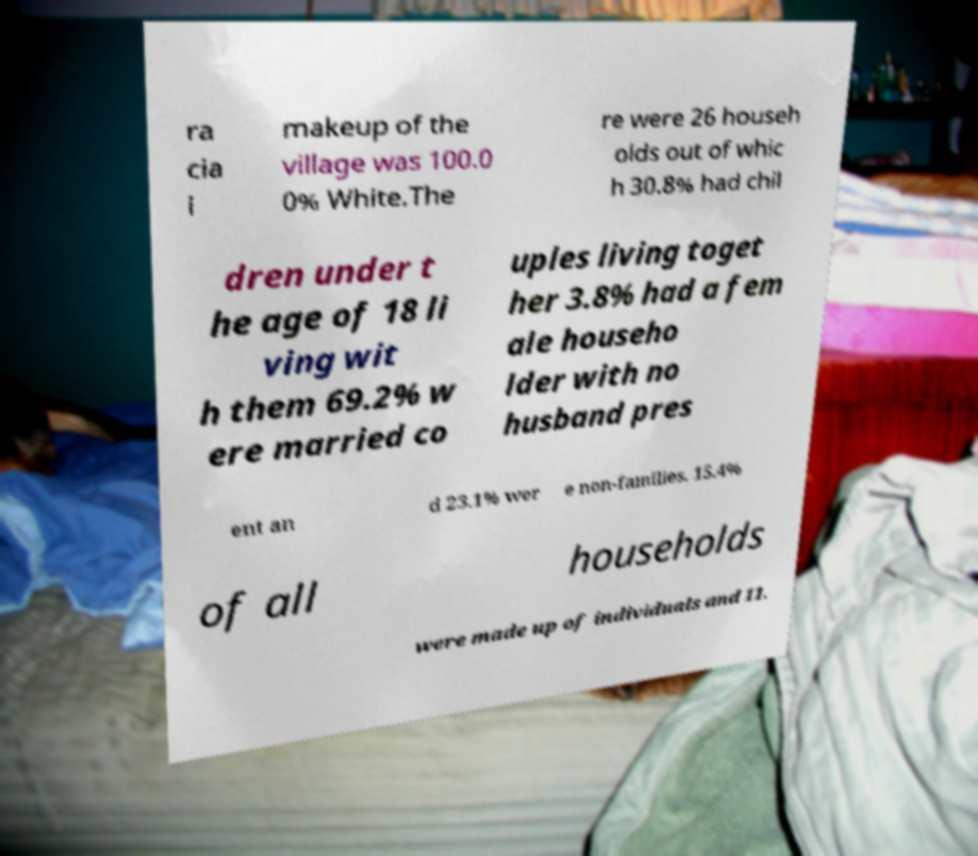Could you extract and type out the text from this image? ra cia l makeup of the village was 100.0 0% White.The re were 26 househ olds out of whic h 30.8% had chil dren under t he age of 18 li ving wit h them 69.2% w ere married co uples living toget her 3.8% had a fem ale househo lder with no husband pres ent an d 23.1% wer e non-families. 15.4% of all households were made up of individuals and 11. 